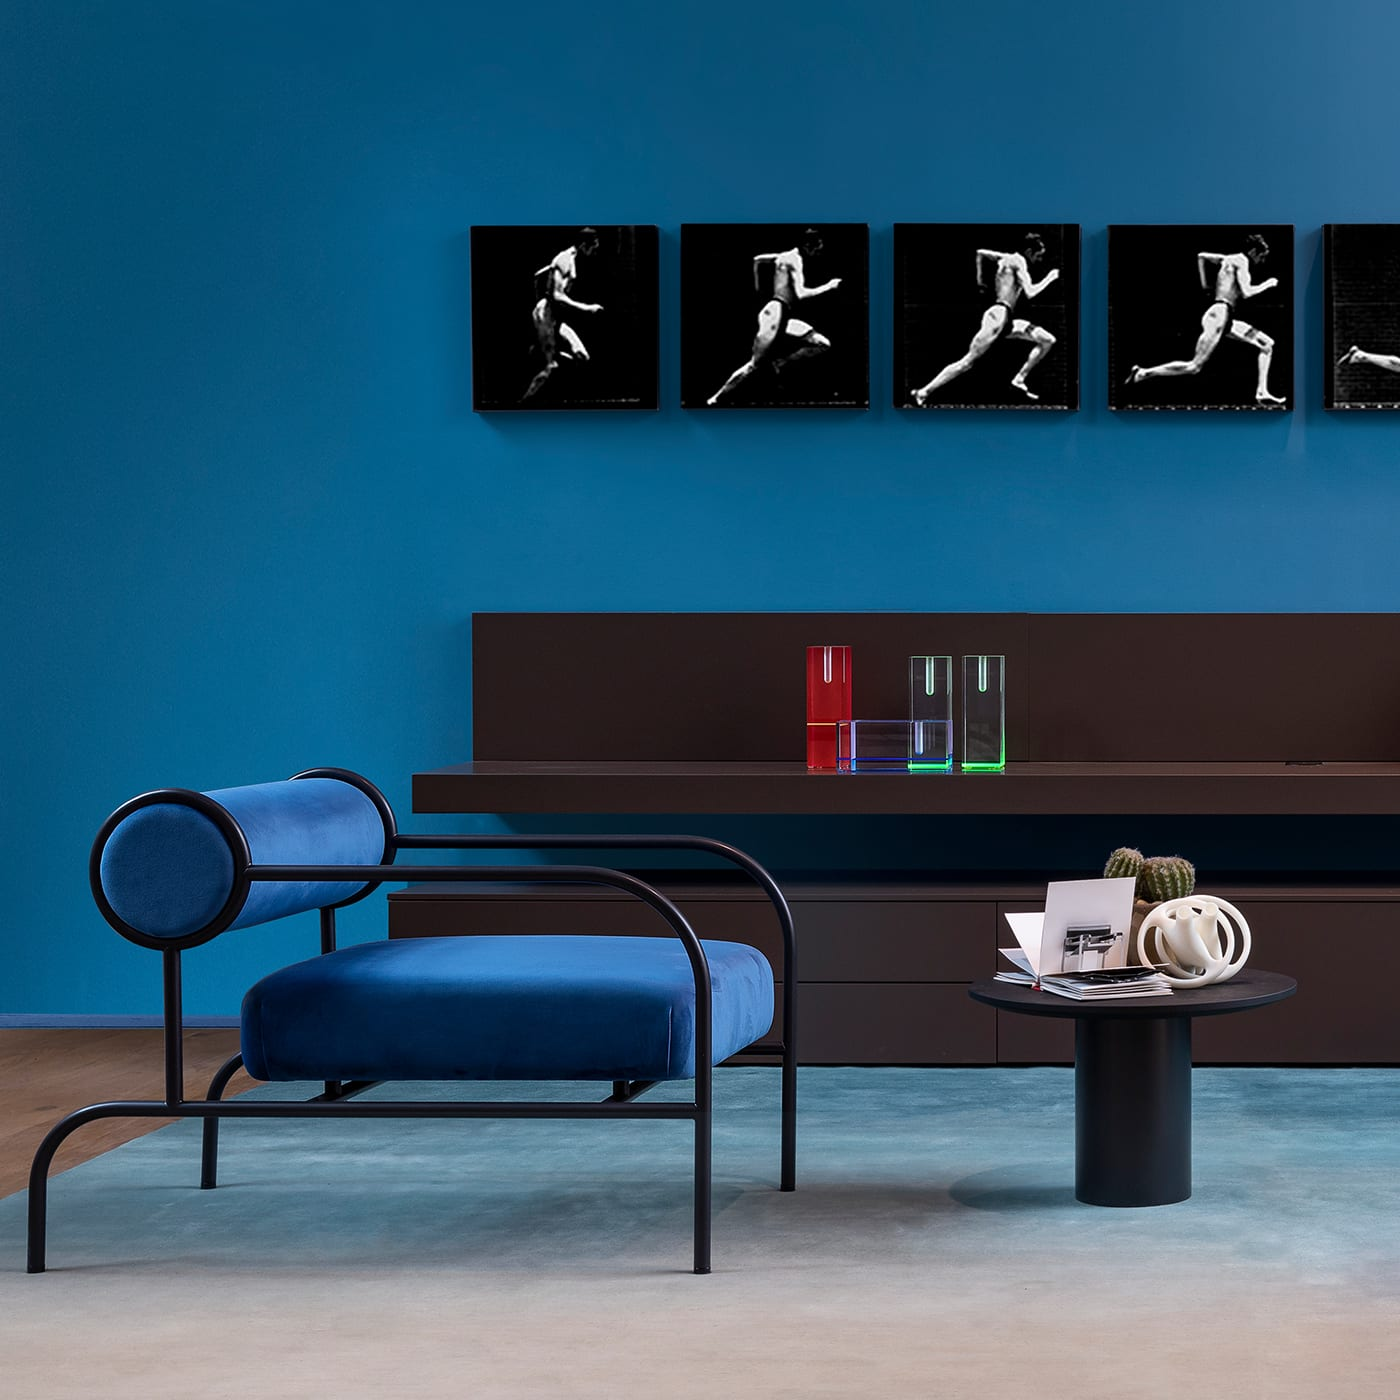What items are on the coffee table? On the sleek, round coffee table, there's a neatly arranged selection of items including a transparent geometric sculpture, an open book displaying a black and white image that complements the artwork on the wall, and what appears to be a sculptural white object with smooth, rounded contours. 